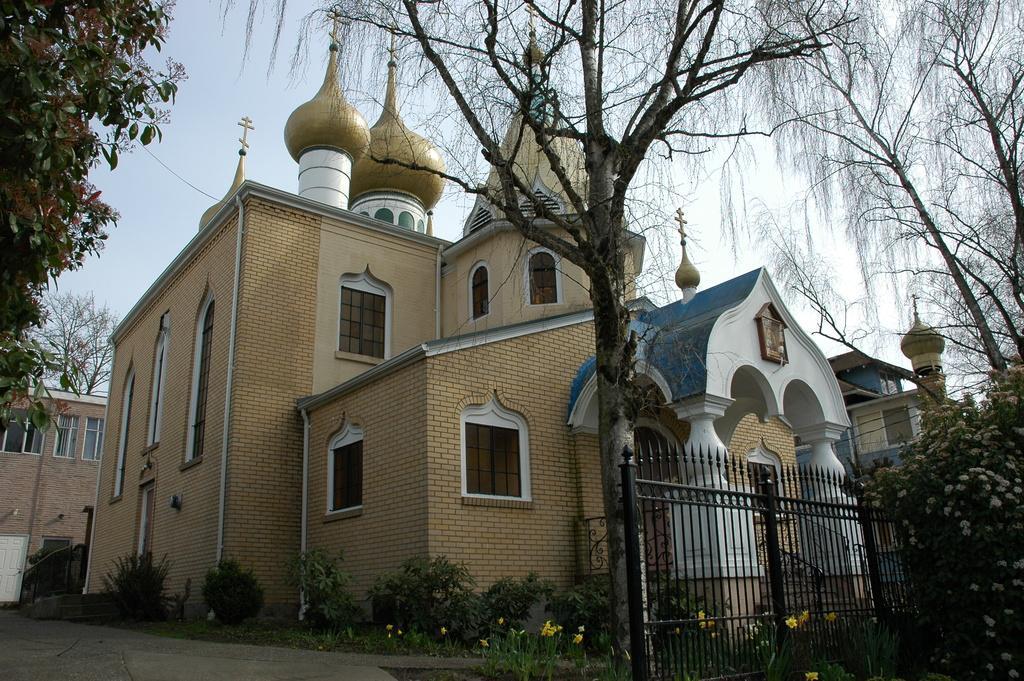How would you summarize this image in a sentence or two? In this picture I can see buildings, trees and few plants and I can see metal fence and a cloudy sky and I can see few flowers. 